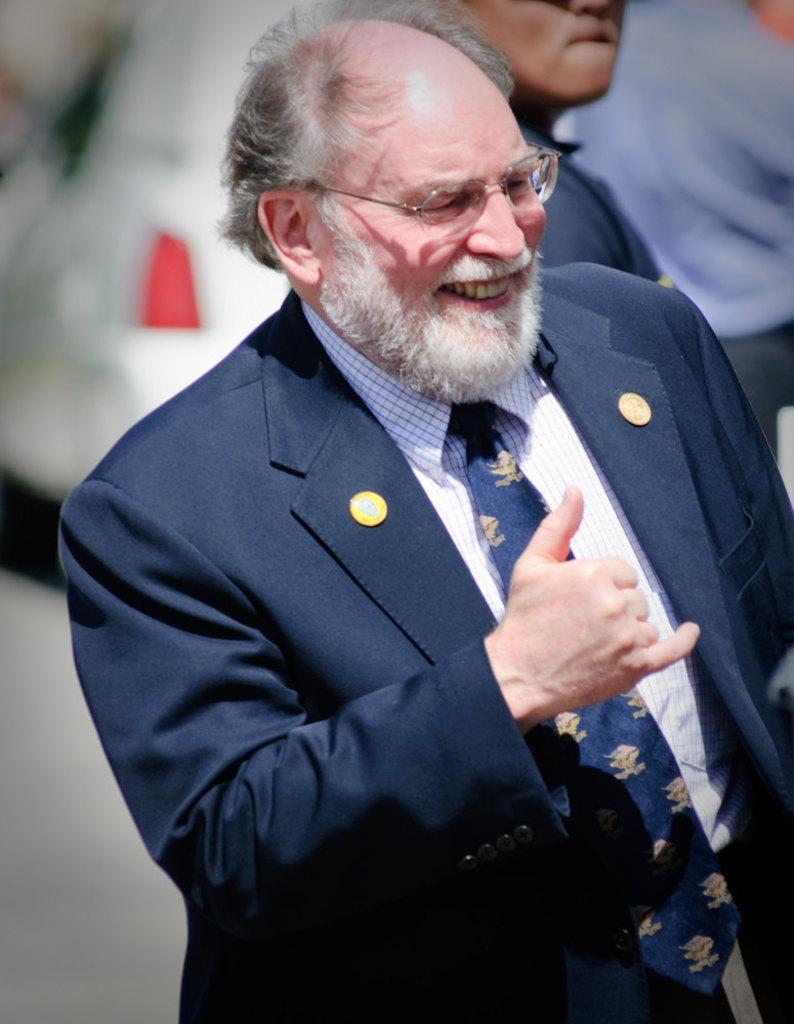What can be observed about the attire of the people in the image? There are people with different color dresses in the image. Can you describe any accessories worn by the people? One person is wearing specs. What is the facial expression of the person wearing specs? The person with specs is smiling. How would you describe the background of the image? The background of the image is blurred. How many cherries are being held by the person wearing specs in the image? There are no cherries present in the image. What type of adjustment is being made by the daughter in the image? There is no daughter present in the image, and no adjustment is being made. 